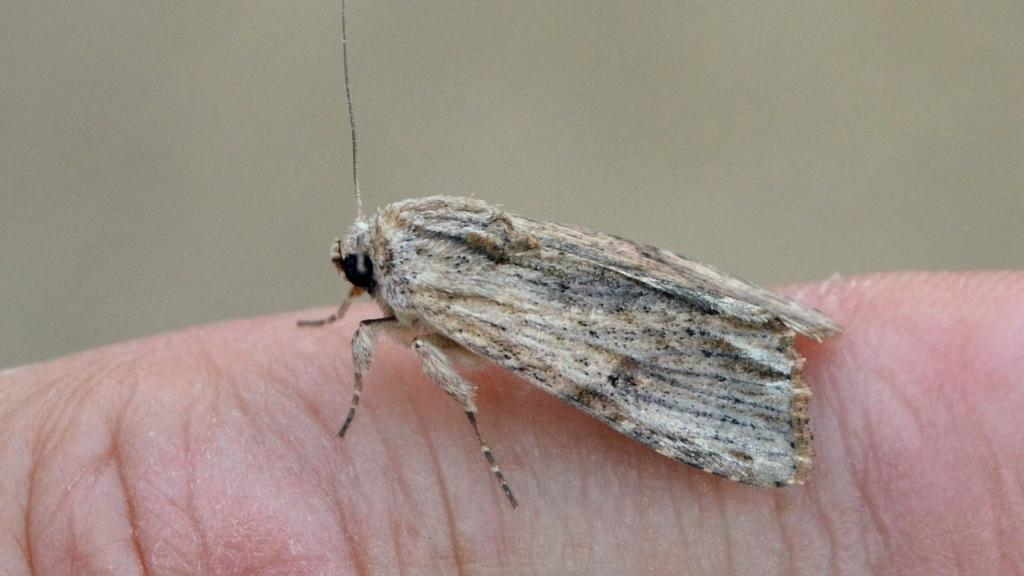What is present in the image that is small and has wings? There is a fly in the image. Where is the fly located in the image? The fly is on a person. What type of plane can be seen flying in the image? There is no plane present in the image; it only features a fly on a person. 